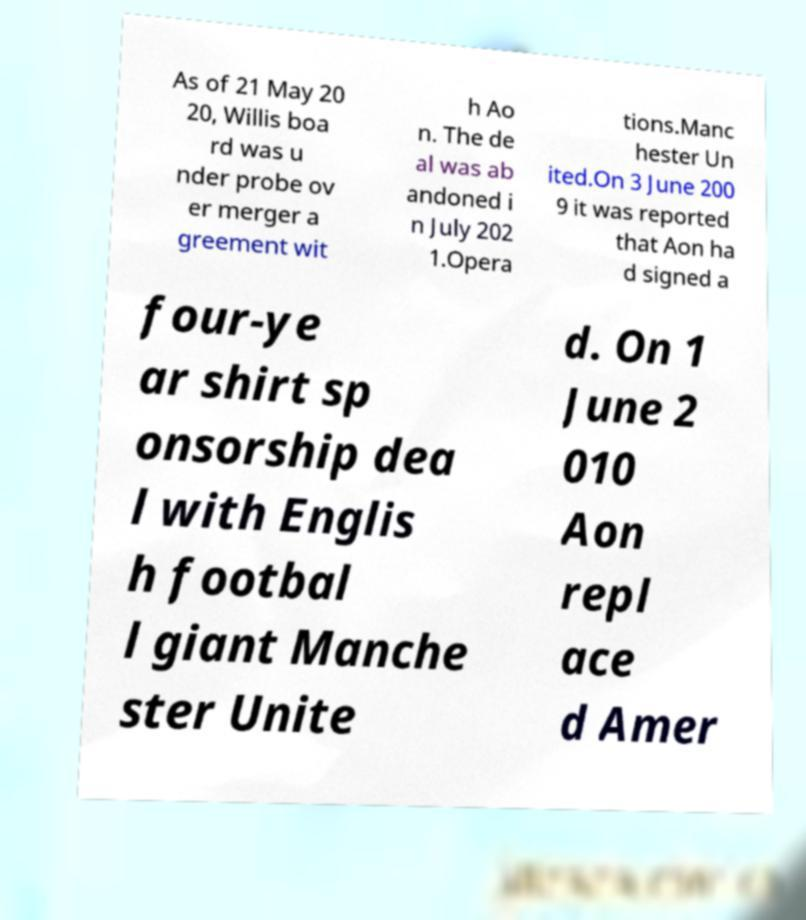Could you extract and type out the text from this image? As of 21 May 20 20, Willis boa rd was u nder probe ov er merger a greement wit h Ao n. The de al was ab andoned i n July 202 1.Opera tions.Manc hester Un ited.On 3 June 200 9 it was reported that Aon ha d signed a four-ye ar shirt sp onsorship dea l with Englis h footbal l giant Manche ster Unite d. On 1 June 2 010 Aon repl ace d Amer 